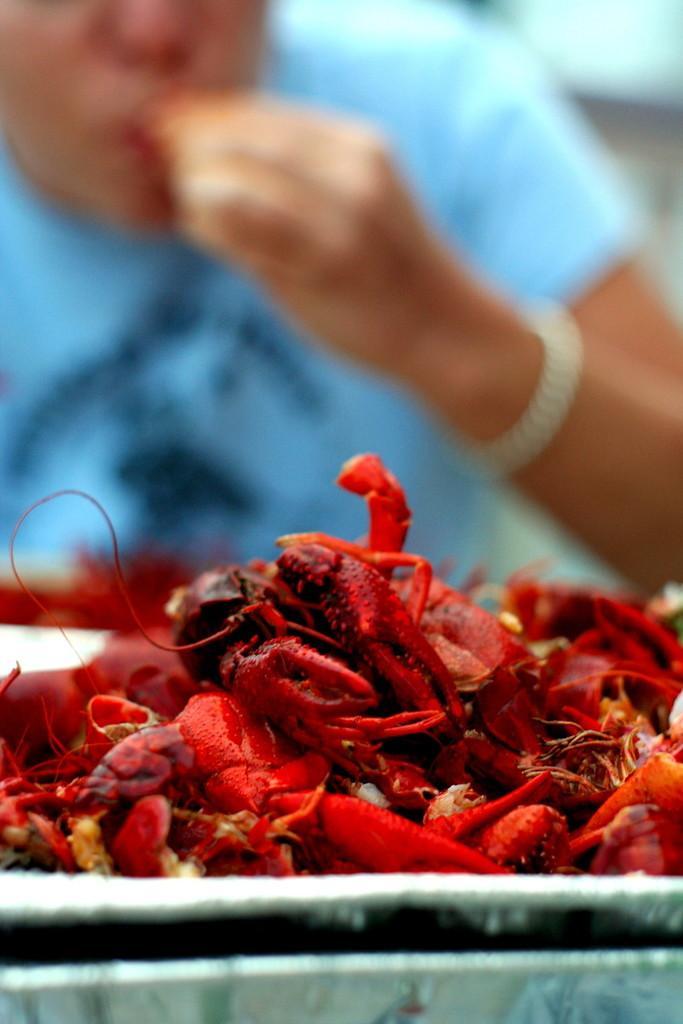Can you describe this image briefly? In the center of the image we can see crabs placed on the table. In the background there is a person. 